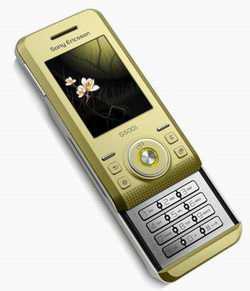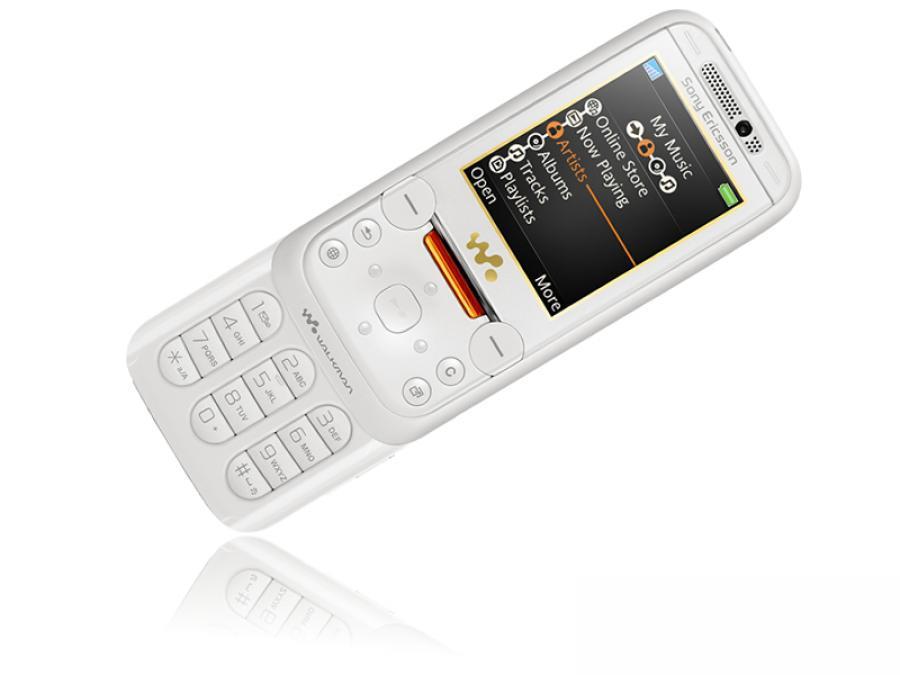The first image is the image on the left, the second image is the image on the right. For the images shown, is this caption "The screen of one of the phones is off." true? Answer yes or no. No. The first image is the image on the left, the second image is the image on the right. Considering the images on both sides, is "Hello Kitty is on at least one of the phones." valid? Answer yes or no. No. 